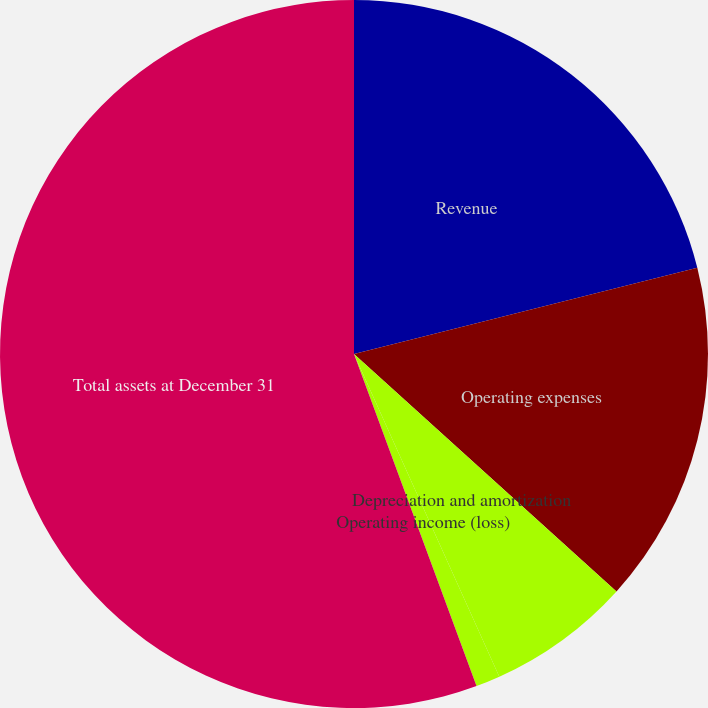Convert chart. <chart><loc_0><loc_0><loc_500><loc_500><pie_chart><fcel>Revenue<fcel>Operating expenses<fcel>Depreciation and amortization<fcel>Operating income (loss)<fcel>Total assets at December 31<nl><fcel>21.08%<fcel>15.63%<fcel>6.56%<fcel>1.11%<fcel>55.63%<nl></chart> 